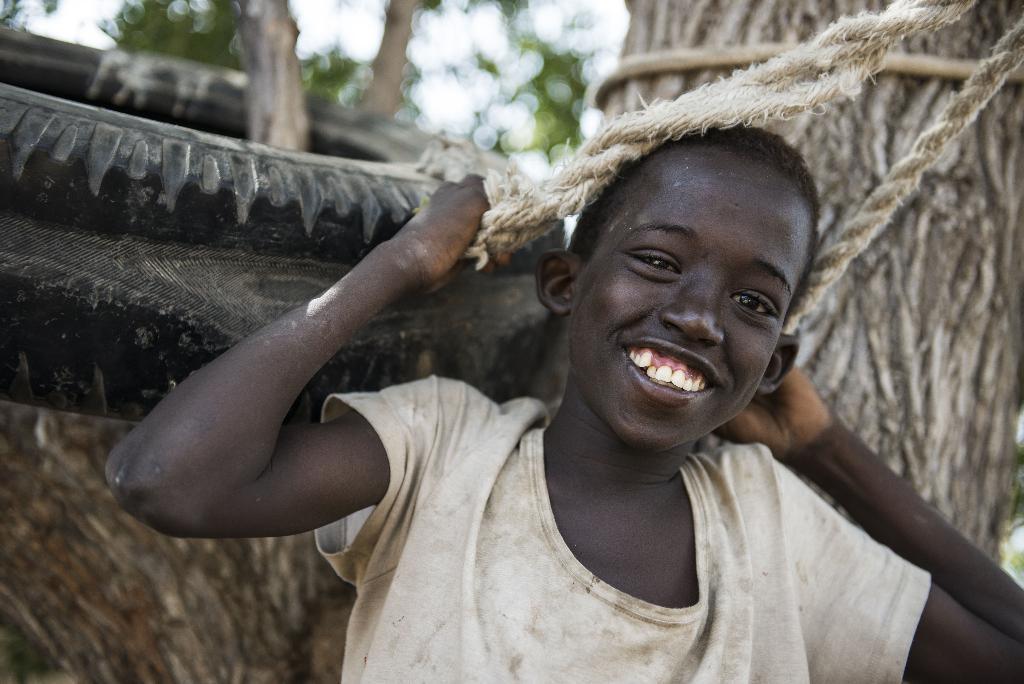Can you describe this image briefly? In front of the picture, we see a boy is smiling and he is posing for the photo. He is holding the ropes in his hands. Beside him, we see a tyre. Behind him, we see the stems of the trees. In the background, we see the trees and the sky. This picture is blurred in the background. 